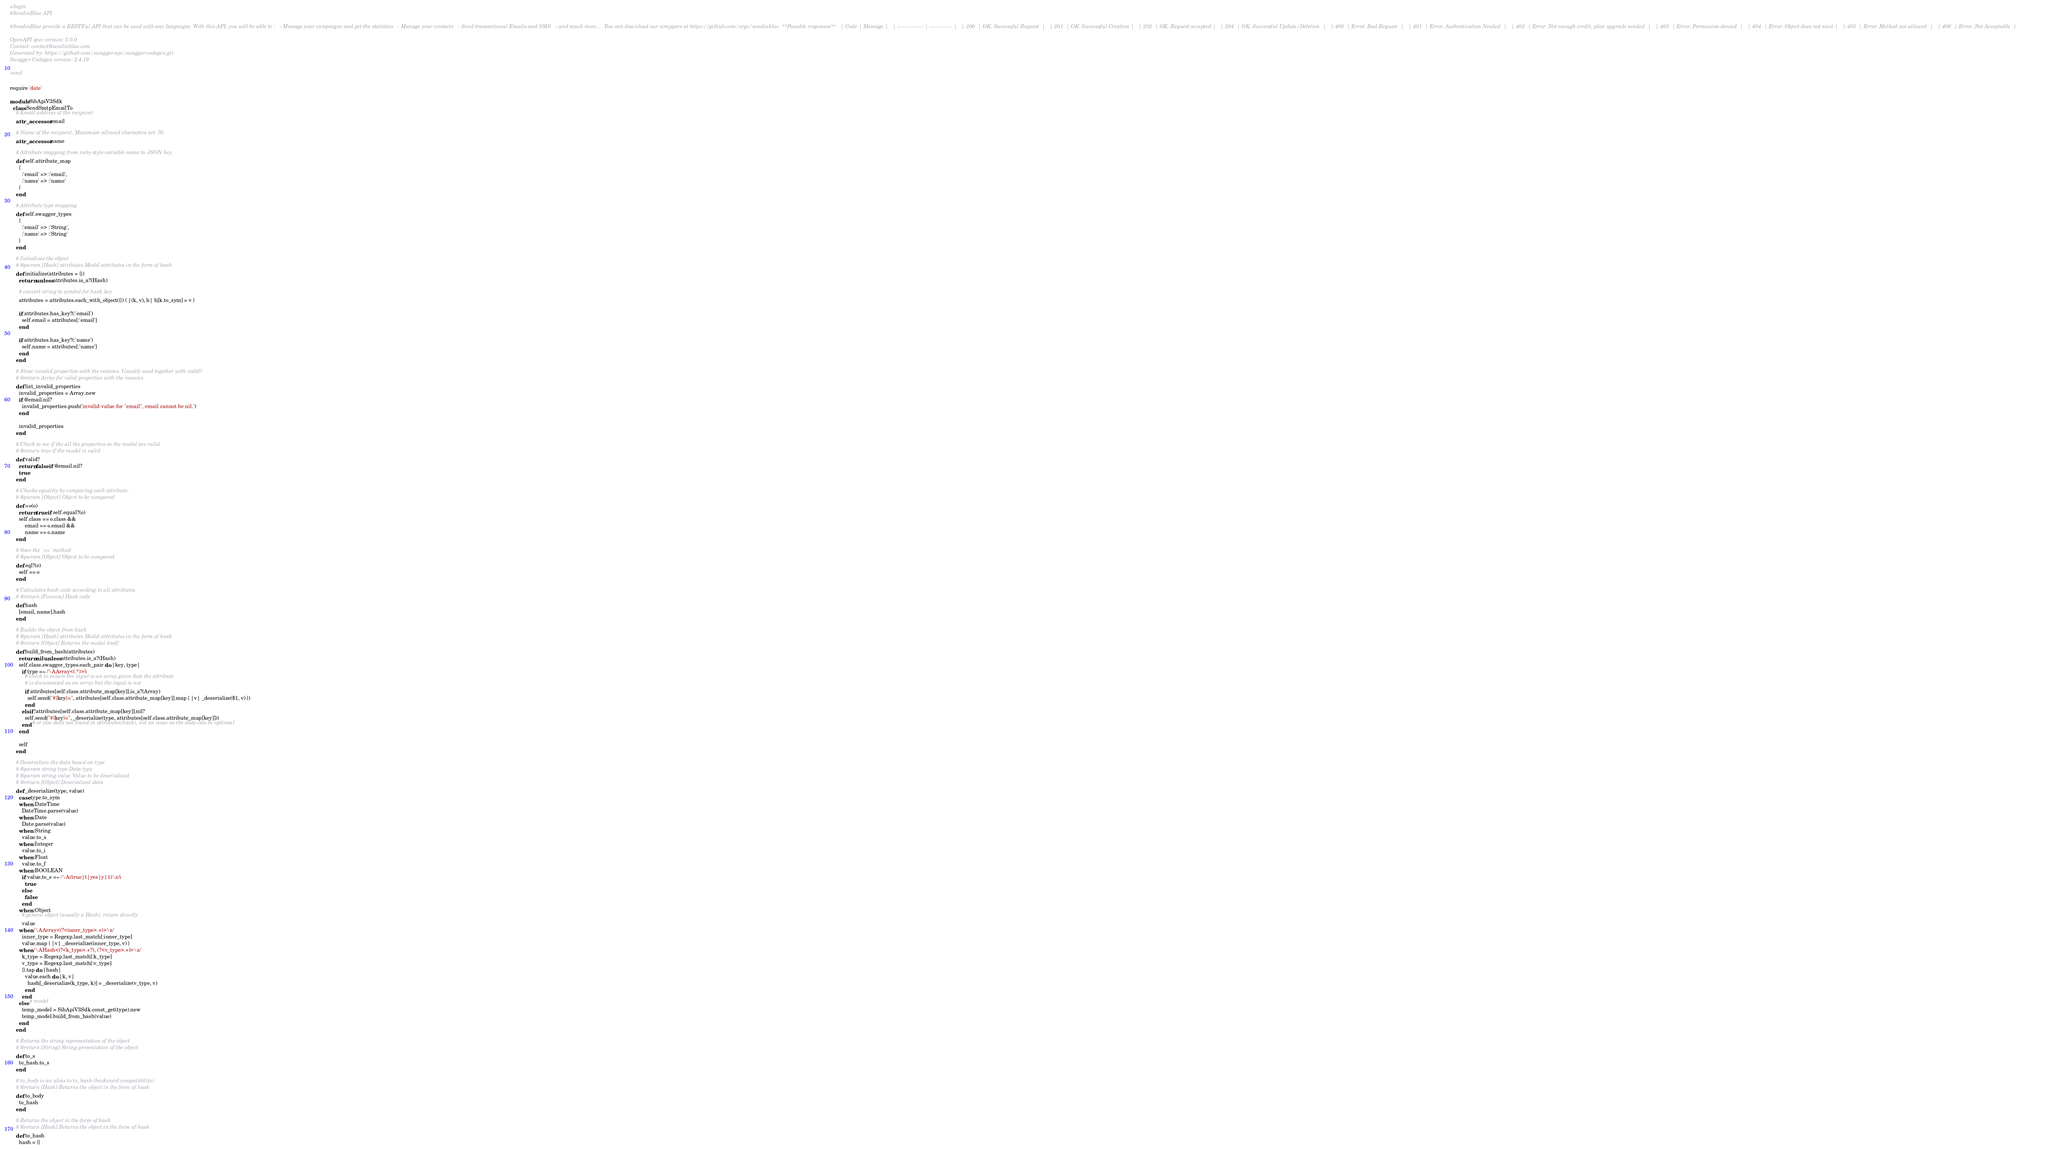<code> <loc_0><loc_0><loc_500><loc_500><_Ruby_>=begin
#SendinBlue API

#SendinBlue provide a RESTFul API that can be used with any languages. With this API, you will be able to :   - Manage your campaigns and get the statistics   - Manage your contacts   - Send transactional Emails and SMS   - and much more...  You can download our wrappers at https://github.com/orgs/sendinblue  **Possible responses**   | Code | Message |   | :-------------: | ------------- |   | 200  | OK. Successful Request  |   | 201  | OK. Successful Creation |   | 202  | OK. Request accepted |   | 204  | OK. Successful Update/Deletion  |   | 400  | Error. Bad Request  |   | 401  | Error. Authentication Needed  |   | 402  | Error. Not enough credit, plan upgrade needed  |   | 403  | Error. Permission denied  |   | 404  | Error. Object does not exist |   | 405  | Error. Method not allowed  |   | 406  | Error. Not Acceptable  | 

OpenAPI spec version: 3.0.0
Contact: contact@sendinblue.com
Generated by: https://github.com/swagger-api/swagger-codegen.git
Swagger Codegen version: 2.4.19

=end

require 'date'

module SibApiV3Sdk
  class SendSmtpEmailTo
    # Email address of the recipient
    attr_accessor :email

    # Name of the recipient. Maximum allowed characters are 70.
    attr_accessor :name

    # Attribute mapping from ruby-style variable name to JSON key.
    def self.attribute_map
      {
        :'email' => :'email',
        :'name' => :'name'
      }
    end

    # Attribute type mapping.
    def self.swagger_types
      {
        :'email' => :'String',
        :'name' => :'String'
      }
    end

    # Initializes the object
    # @param [Hash] attributes Model attributes in the form of hash
    def initialize(attributes = {})
      return unless attributes.is_a?(Hash)

      # convert string to symbol for hash key
      attributes = attributes.each_with_object({}) { |(k, v), h| h[k.to_sym] = v }

      if attributes.has_key?(:'email')
        self.email = attributes[:'email']
      end

      if attributes.has_key?(:'name')
        self.name = attributes[:'name']
      end
    end

    # Show invalid properties with the reasons. Usually used together with valid?
    # @return Array for valid properties with the reasons
    def list_invalid_properties
      invalid_properties = Array.new
      if @email.nil?
        invalid_properties.push('invalid value for "email", email cannot be nil.')
      end

      invalid_properties
    end

    # Check to see if the all the properties in the model are valid
    # @return true if the model is valid
    def valid?
      return false if @email.nil?
      true
    end

    # Checks equality by comparing each attribute.
    # @param [Object] Object to be compared
    def ==(o)
      return true if self.equal?(o)
      self.class == o.class &&
          email == o.email &&
          name == o.name
    end

    # @see the `==` method
    # @param [Object] Object to be compared
    def eql?(o)
      self == o
    end

    # Calculates hash code according to all attributes.
    # @return [Fixnum] Hash code
    def hash
      [email, name].hash
    end

    # Builds the object from hash
    # @param [Hash] attributes Model attributes in the form of hash
    # @return [Object] Returns the model itself
    def build_from_hash(attributes)
      return nil unless attributes.is_a?(Hash)
      self.class.swagger_types.each_pair do |key, type|
        if type =~ /\AArray<(.*)>/i
          # check to ensure the input is an array given that the attribute
          # is documented as an array but the input is not
          if attributes[self.class.attribute_map[key]].is_a?(Array)
            self.send("#{key}=", attributes[self.class.attribute_map[key]].map { |v| _deserialize($1, v) })
          end
        elsif !attributes[self.class.attribute_map[key]].nil?
          self.send("#{key}=", _deserialize(type, attributes[self.class.attribute_map[key]]))
        end # or else data not found in attributes(hash), not an issue as the data can be optional
      end

      self
    end

    # Deserializes the data based on type
    # @param string type Data type
    # @param string value Value to be deserialized
    # @return [Object] Deserialized data
    def _deserialize(type, value)
      case type.to_sym
      when :DateTime
        DateTime.parse(value)
      when :Date
        Date.parse(value)
      when :String
        value.to_s
      when :Integer
        value.to_i
      when :Float
        value.to_f
      when :BOOLEAN
        if value.to_s =~ /\A(true|t|yes|y|1)\z/i
          true
        else
          false
        end
      when :Object
        # generic object (usually a Hash), return directly
        value
      when /\AArray<(?<inner_type>.+)>\z/
        inner_type = Regexp.last_match[:inner_type]
        value.map { |v| _deserialize(inner_type, v) }
      when /\AHash<(?<k_type>.+?), (?<v_type>.+)>\z/
        k_type = Regexp.last_match[:k_type]
        v_type = Regexp.last_match[:v_type]
        {}.tap do |hash|
          value.each do |k, v|
            hash[_deserialize(k_type, k)] = _deserialize(v_type, v)
          end
        end
      else # model
        temp_model = SibApiV3Sdk.const_get(type).new
        temp_model.build_from_hash(value)
      end
    end

    # Returns the string representation of the object
    # @return [String] String presentation of the object
    def to_s
      to_hash.to_s
    end

    # to_body is an alias to to_hash (backward compatibility)
    # @return [Hash] Returns the object in the form of hash
    def to_body
      to_hash
    end

    # Returns the object in the form of hash
    # @return [Hash] Returns the object in the form of hash
    def to_hash
      hash = {}</code> 